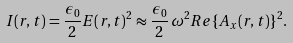Convert formula to latex. <formula><loc_0><loc_0><loc_500><loc_500>I ( { r } , t ) = \frac { \epsilon _ { 0 } } { 2 } { E } ( { r } , t ) ^ { 2 } \approx \frac { \epsilon _ { 0 } } { 2 } \, \omega ^ { 2 } R e \{ A _ { x } ( { r } , t ) \} ^ { 2 } .</formula> 